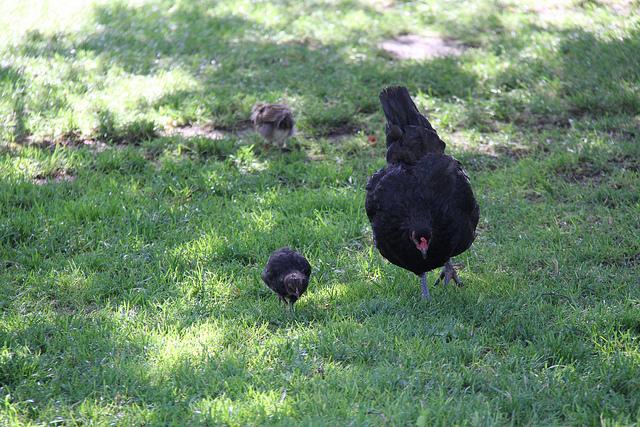What type of bird is this?
Write a very short answer. Chicken. Is this a rooster?
Write a very short answer. No. How many feathered animals can you see?
Quick response, please. 2. 